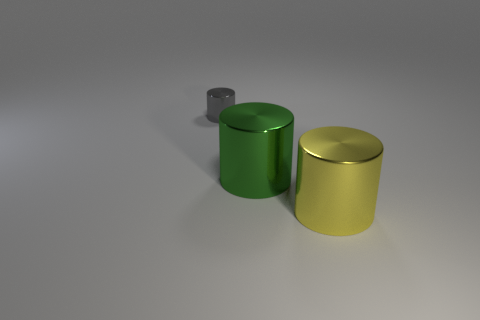Subtract all large metallic cylinders. How many cylinders are left? 1 Add 3 purple rubber cylinders. How many objects exist? 6 Subtract all big yellow metallic objects. Subtract all gray shiny cylinders. How many objects are left? 1 Add 2 large things. How many large things are left? 4 Add 3 green things. How many green things exist? 4 Subtract 0 gray balls. How many objects are left? 3 